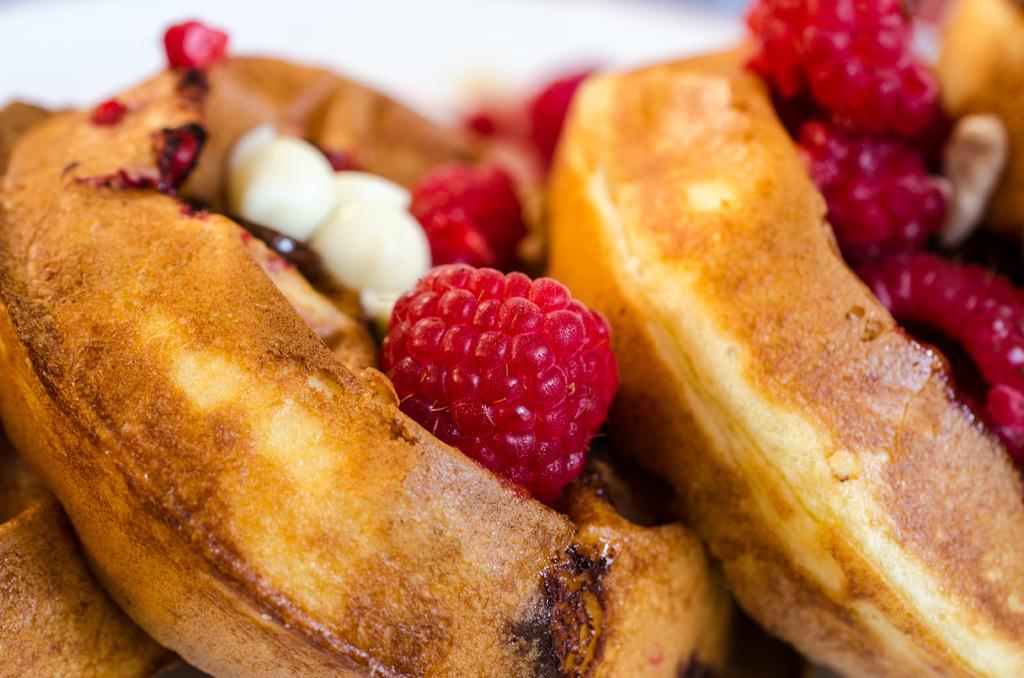How would you summarize this image in a sentence or two? In this image we can see food and some raspberries on it. 